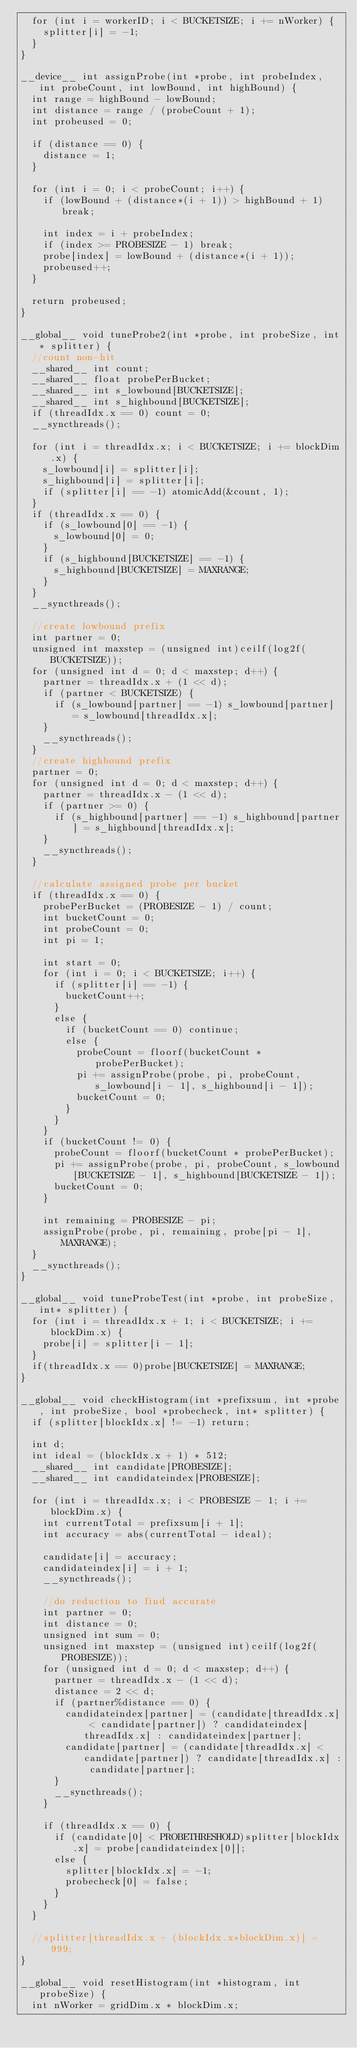Convert code to text. <code><loc_0><loc_0><loc_500><loc_500><_Cuda_>	for (int i = workerID; i < BUCKETSIZE; i += nWorker) {
		splitter[i] = -1;
	}
}

__device__ int assignProbe(int *probe, int probeIndex, int probeCount, int lowBound, int highBound) {
	int range = highBound - lowBound;
	int distance = range / (probeCount + 1);
	int probeused = 0;

	if (distance == 0) {
		distance = 1;
	}

	for (int i = 0; i < probeCount; i++) {
		if (lowBound + (distance*(i + 1)) > highBound + 1) break;

		int index = i + probeIndex;
		if (index >= PROBESIZE - 1) break;
		probe[index] = lowBound + (distance*(i + 1));
		probeused++;
	}

	return probeused;
}

__global__ void tuneProbe2(int *probe, int probeSize, int* splitter) {
	//count non-hit
	__shared__ int count;
	__shared__ float probePerBucket;
	__shared__ int s_lowbound[BUCKETSIZE];
	__shared__ int s_highbound[BUCKETSIZE];
	if (threadIdx.x == 0) count = 0;
	__syncthreads();

	for (int i = threadIdx.x; i < BUCKETSIZE; i += blockDim.x) {
		s_lowbound[i] = splitter[i];
		s_highbound[i] = splitter[i];
		if (splitter[i] == -1) atomicAdd(&count, 1);
	}
	if (threadIdx.x == 0) {
		if (s_lowbound[0] == -1) {
			s_lowbound[0] = 0;
		}
		if (s_highbound[BUCKETSIZE] == -1) {
			s_highbound[BUCKETSIZE] = MAXRANGE;
		}
	}
	__syncthreads();

	//create lowbound prefix
	int partner = 0;
	unsigned int maxstep = (unsigned int)ceilf(log2f(BUCKETSIZE));
	for (unsigned int d = 0; d < maxstep; d++) {
		partner = threadIdx.x + (1 << d);
		if (partner < BUCKETSIZE) {
			if (s_lowbound[partner] == -1) s_lowbound[partner] = s_lowbound[threadIdx.x];
		}
		__syncthreads();
	}
	//create highbound prefix
	partner = 0;
	for (unsigned int d = 0; d < maxstep; d++) {
		partner = threadIdx.x - (1 << d);
		if (partner >= 0) {
			if (s_highbound[partner] == -1) s_highbound[partner] = s_highbound[threadIdx.x];
		}
		__syncthreads();
	}

	//calculate assigned probe per bucket
	if (threadIdx.x == 0) {
		probePerBucket = (PROBESIZE - 1) / count;
		int bucketCount = 0;
		int probeCount = 0;
		int pi = 1;

		int start = 0;
		for (int i = 0; i < BUCKETSIZE; i++) {
			if (splitter[i] == -1) {
				bucketCount++;
			}
			else {
				if (bucketCount == 0) continue;
				else {
					probeCount = floorf(bucketCount * probePerBucket);
					pi += assignProbe(probe, pi, probeCount, s_lowbound[i - 1], s_highbound[i - 1]);
					bucketCount = 0;
				}
			}
		}
		if (bucketCount != 0) {
			probeCount = floorf(bucketCount * probePerBucket);
			pi += assignProbe(probe, pi, probeCount, s_lowbound[BUCKETSIZE - 1], s_highbound[BUCKETSIZE - 1]);
			bucketCount = 0;
		}

		int remaining = PROBESIZE - pi;
		assignProbe(probe, pi, remaining, probe[pi - 1], MAXRANGE);
	}
	__syncthreads();
}

__global__ void tuneProbeTest(int *probe, int probeSize, int* splitter) {
	for (int i = threadIdx.x + 1; i < BUCKETSIZE; i += blockDim.x) {
		probe[i] = splitter[i - 1];
	}
	if(threadIdx.x == 0)probe[BUCKETSIZE] = MAXRANGE;
}

__global__ void checkHistogram(int *prefixsum, int *probe, int probeSize, bool *probecheck, int* splitter) {
	if (splitter[blockIdx.x] != -1) return;

	int d;
	int ideal = (blockIdx.x + 1) * 512;
	__shared__ int candidate[PROBESIZE];
	__shared__ int candidateindex[PROBESIZE];

	for (int i = threadIdx.x; i < PROBESIZE - 1; i += blockDim.x) {
		int currentTotal = prefixsum[i + 1];
		int accuracy = abs(currentTotal - ideal);

		candidate[i] = accuracy;
		candidateindex[i] = i + 1;
		__syncthreads();

		//do reduction to find accurate
		int partner = 0;
		int distance = 0;
		unsigned int sum = 0;
		unsigned int maxstep = (unsigned int)ceilf(log2f(PROBESIZE));
		for (unsigned int d = 0; d < maxstep; d++) {
			partner = threadIdx.x - (1 << d);
			distance = 2 << d;
			if (partner%distance == 0) {
				candidateindex[partner] = (candidate[threadIdx.x] < candidate[partner]) ? candidateindex[threadIdx.x] : candidateindex[partner];
				candidate[partner] = (candidate[threadIdx.x] < candidate[partner]) ? candidate[threadIdx.x] : candidate[partner];
			}
			__syncthreads();
		}

		if (threadIdx.x == 0) {
			if (candidate[0] < PROBETHRESHOLD)splitter[blockIdx.x] = probe[candidateindex[0]];
			else {
				splitter[blockIdx.x] = -1;
				probecheck[0] = false;
			}
		}
	}

	//splitter[threadIdx.x + (blockIdx.x*blockDim.x)] = 999;
}

__global__ void resetHistogram(int *histogram, int probeSize) {
	int nWorker = gridDim.x * blockDim.x;</code> 